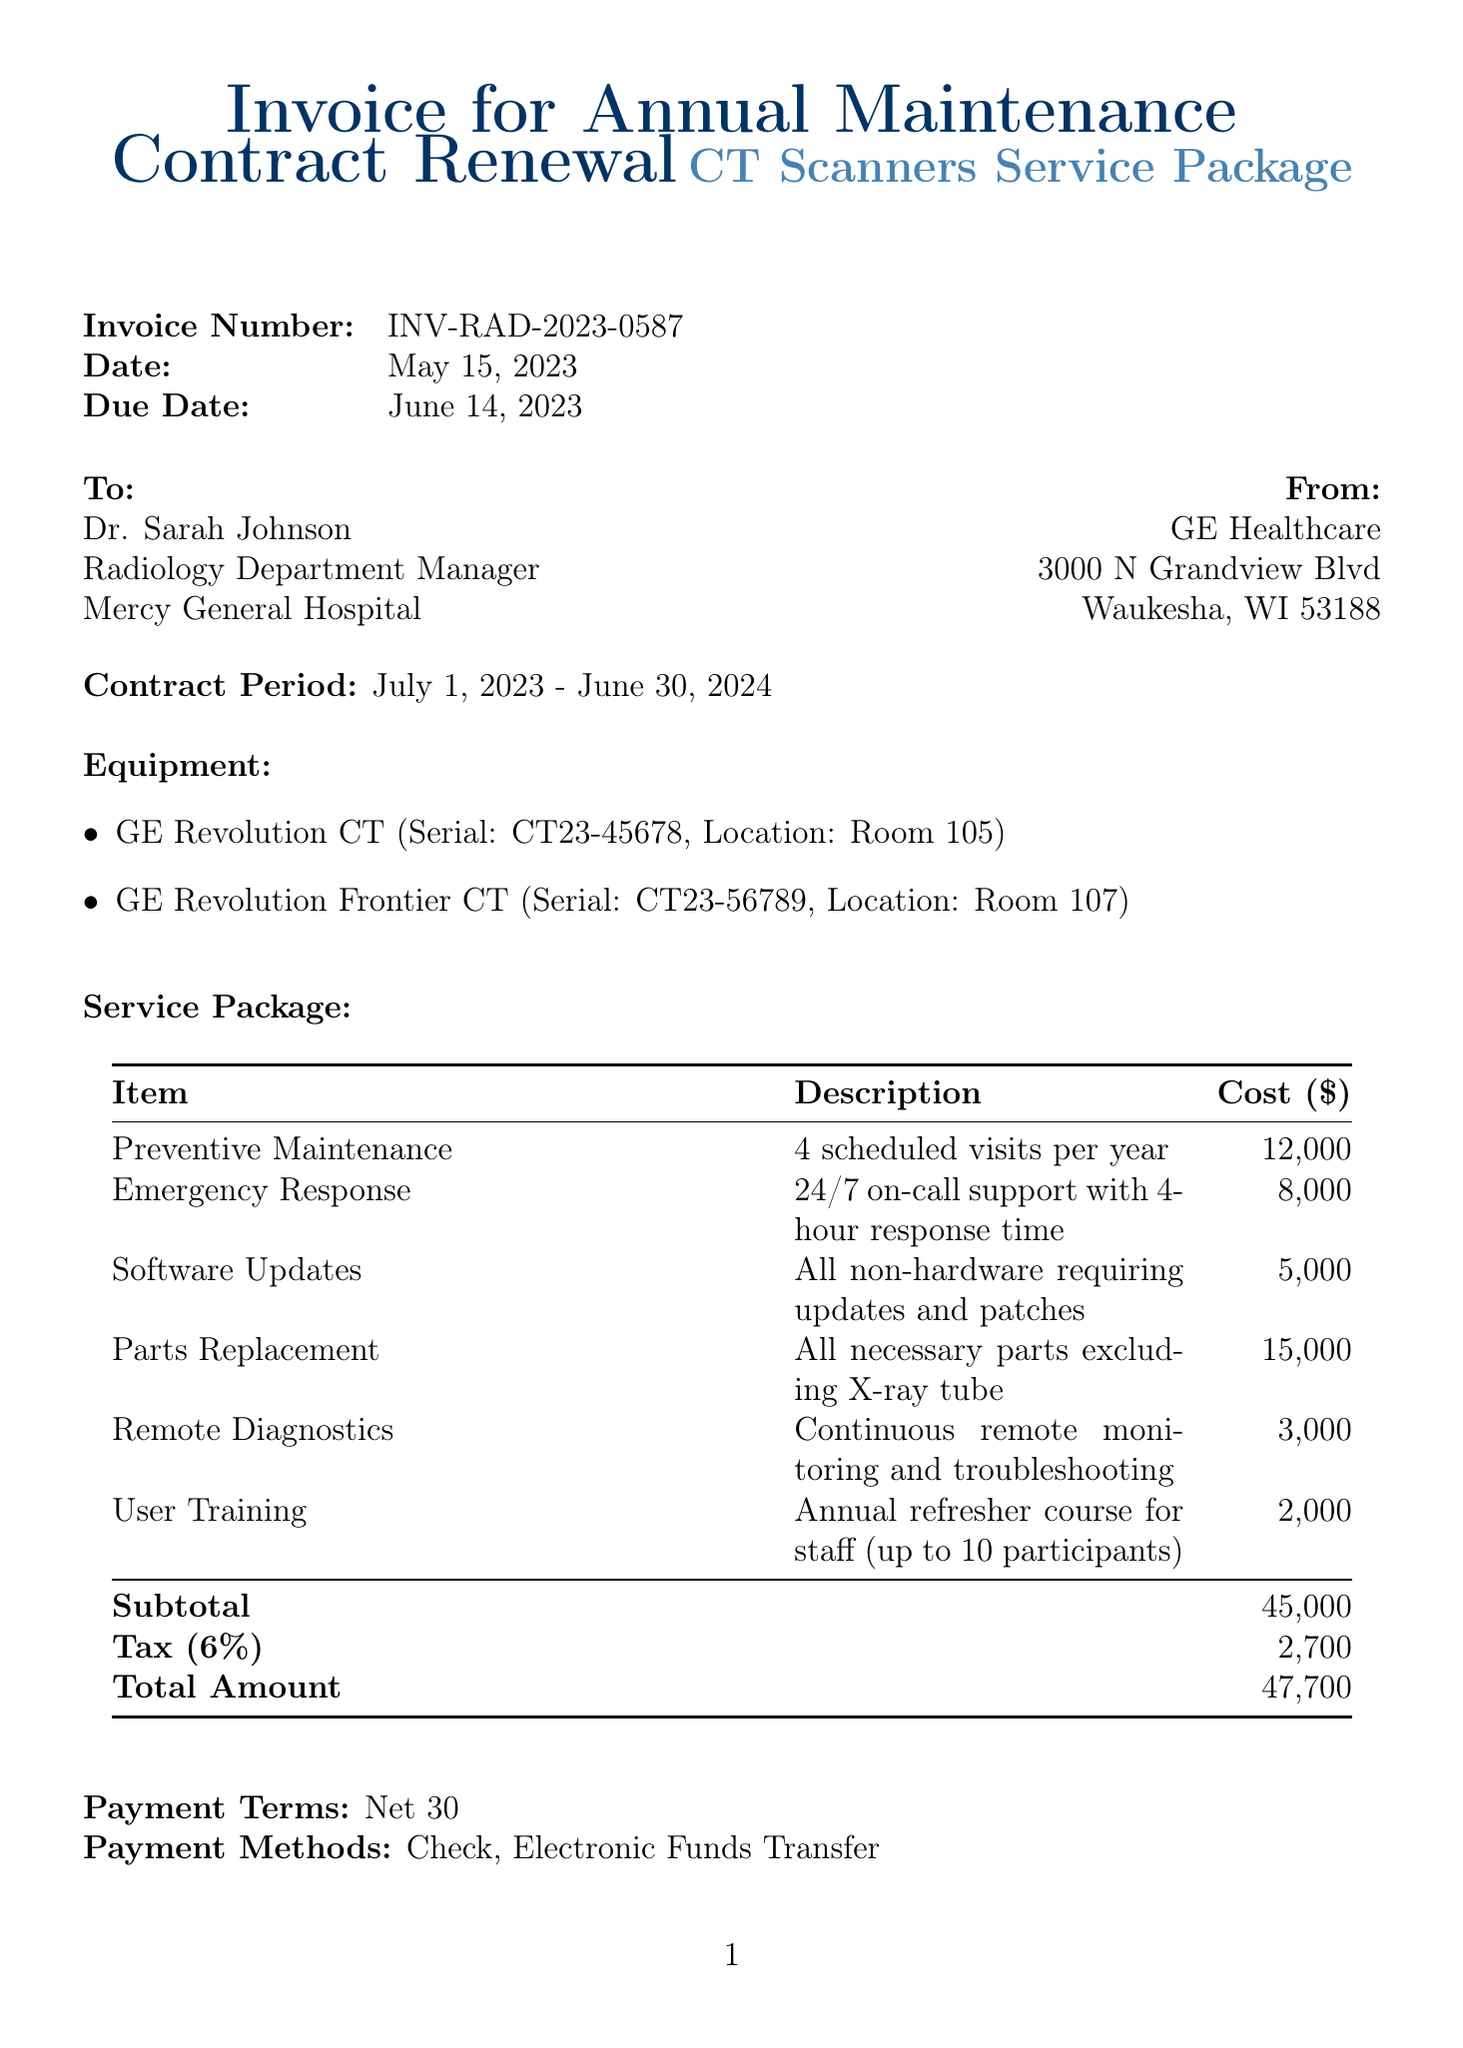What is the invoice number? The invoice number is explicitly stated in the document for easy reference.
Answer: INV-RAD-2023-0587 What is the date of the invoice? The date when the invoice was issued can be found in the document.
Answer: May 15, 2023 What is the total amount due? The total amount due is calculated and clearly listed in the document.
Answer: 47700 Who is the account manager? The account manager's name is mentioned in the document for contact purposes.
Answer: Michael Thompson What services are included in the service package? The document lists the different items in the service package, which can be referenced to understand what's included.
Answer: Preventive Maintenance, Emergency Response, Software Updates, Parts Replacement, Remote Diagnostics, User Training What is the contract period? The duration of the contract is specifically defined in the invoice.
Answer: July 1, 2023 - June 30, 2024 What type of support is included in "Emergency Response"? The description for the Emergency Response item provides details about the type of support offered.
Answer: 24/7 on-call support with 4-hour response time Is there any special note regarding software improvements? A comment regarding additional software upgrades is included in the document for clarity on benefits.
Answer: Upgrade to the latest AI-assisted image reconstruction software at no additional cost 